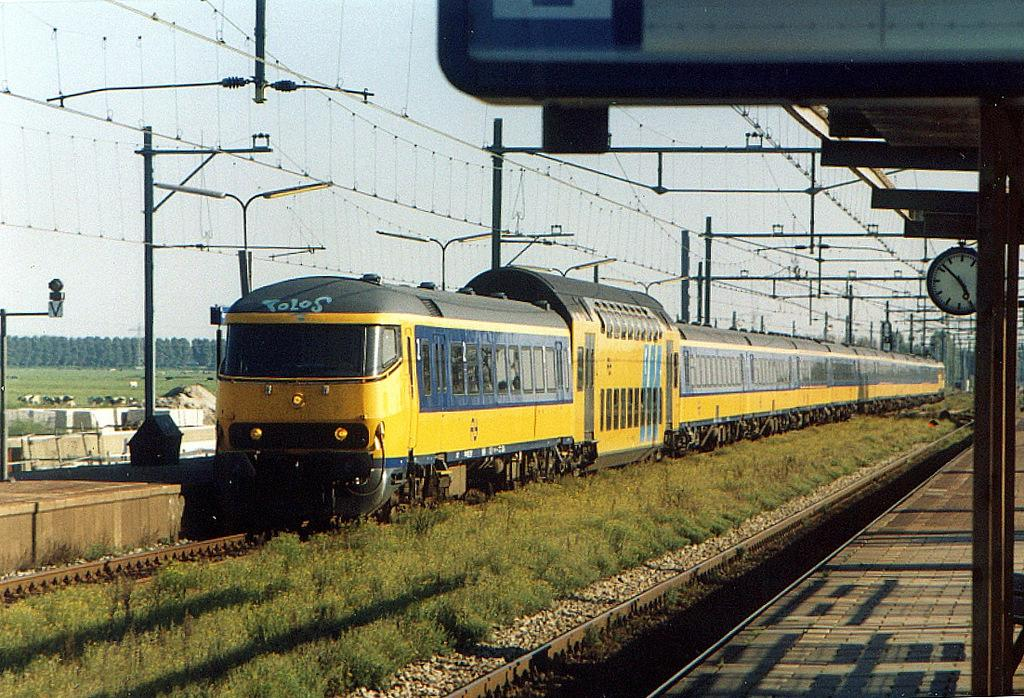Provide a one-sentence caption for the provided image. A yellow train at the train station with a clock that says it is 4:52. 